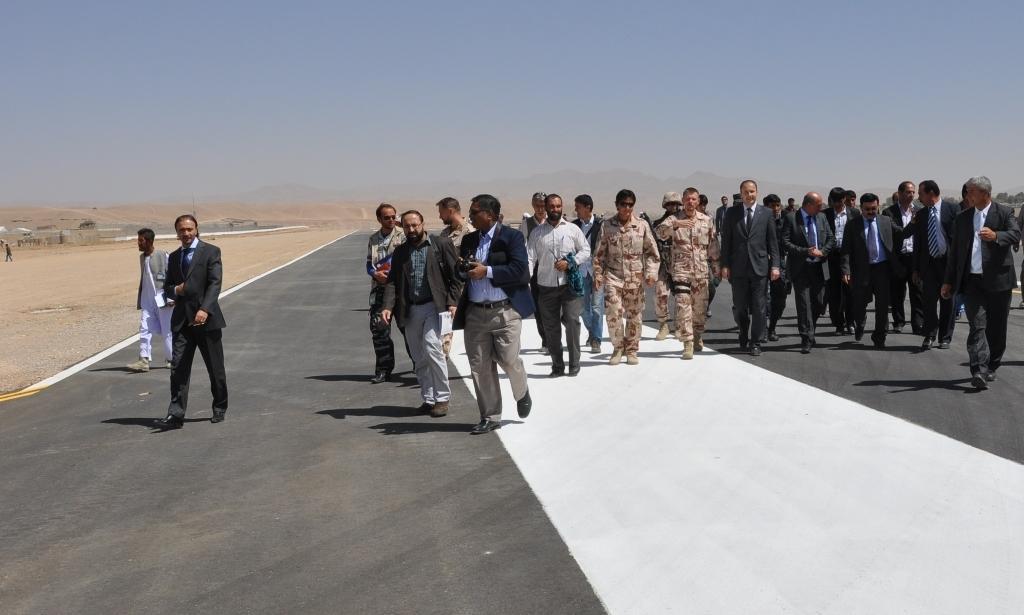How would you summarize this image in a sentence or two? In this picture I can see group of people standing on the road, there are hills, and in the background there is the sky. 